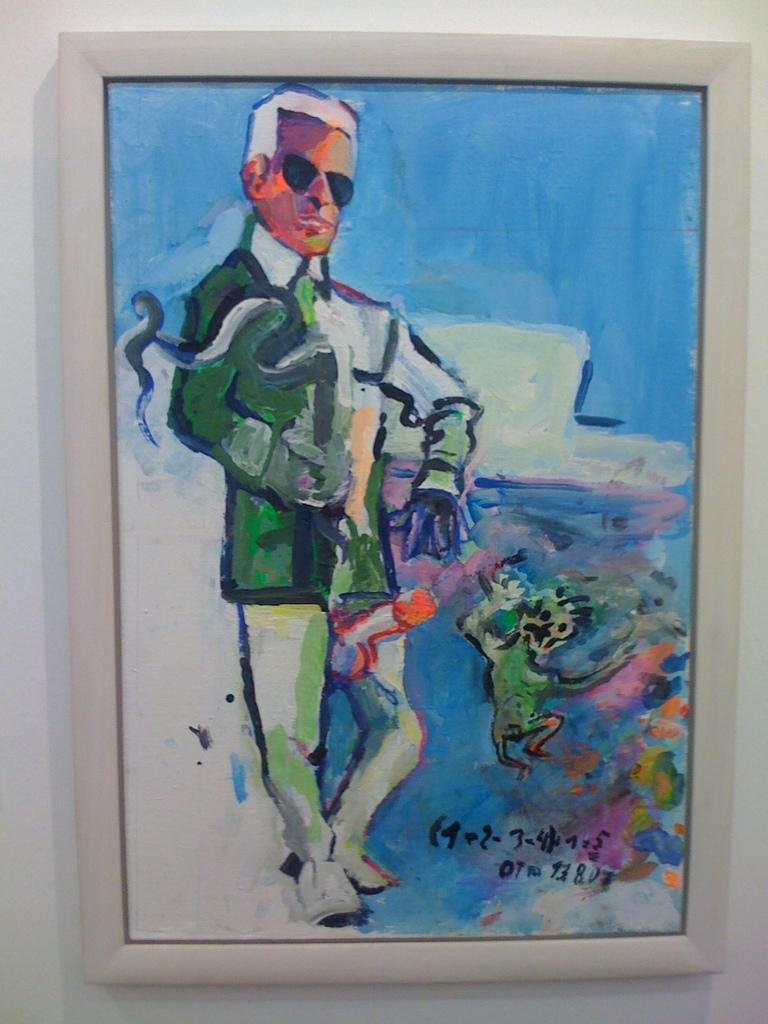What is hanging on the white wall in the image? There is a photo frame on a white wall. What is inside the photo frame? The photo frame contains a painting. What is the subject of the painting? The painting depicts a person. What is the person in the painting wearing on their face? The person in the painting is wearing goggles. What type of clothing is the person in the painting wearing on their upper body? The person in the painting is wearing a blazer. What type of substance is being recited in the painting? There is no substance or verse being recited in the painting; it is a visual representation of a person wearing goggles and a blazer. 